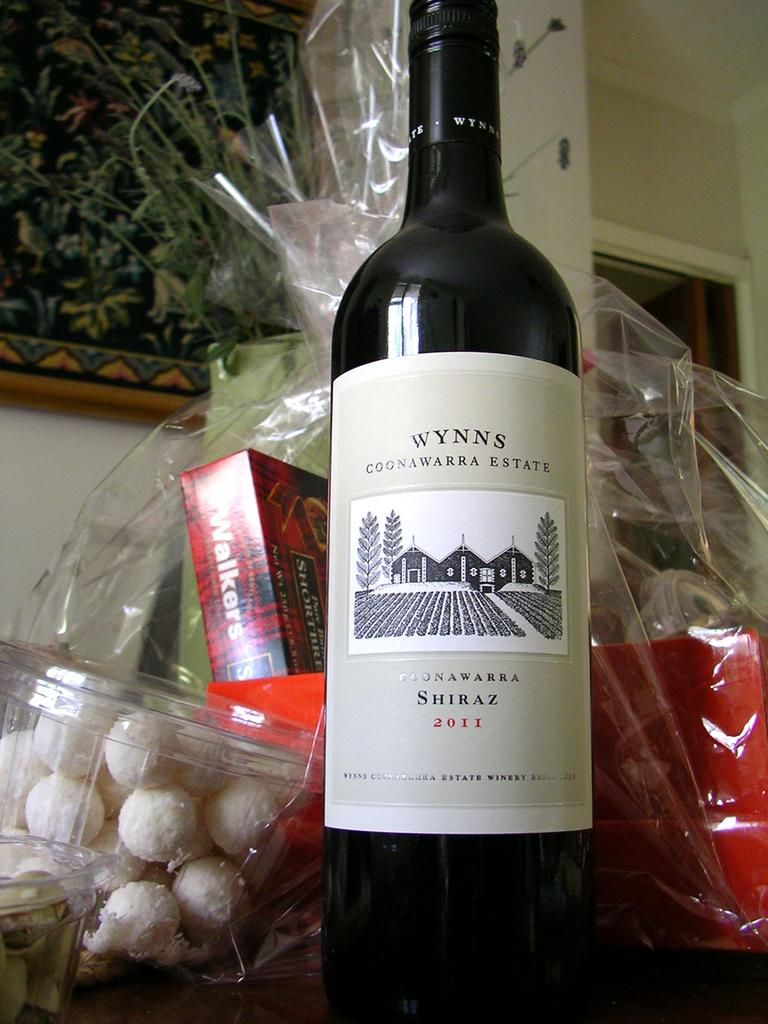<image>
Write a terse but informative summary of the picture. the word wynn's that is on a wine bottle 